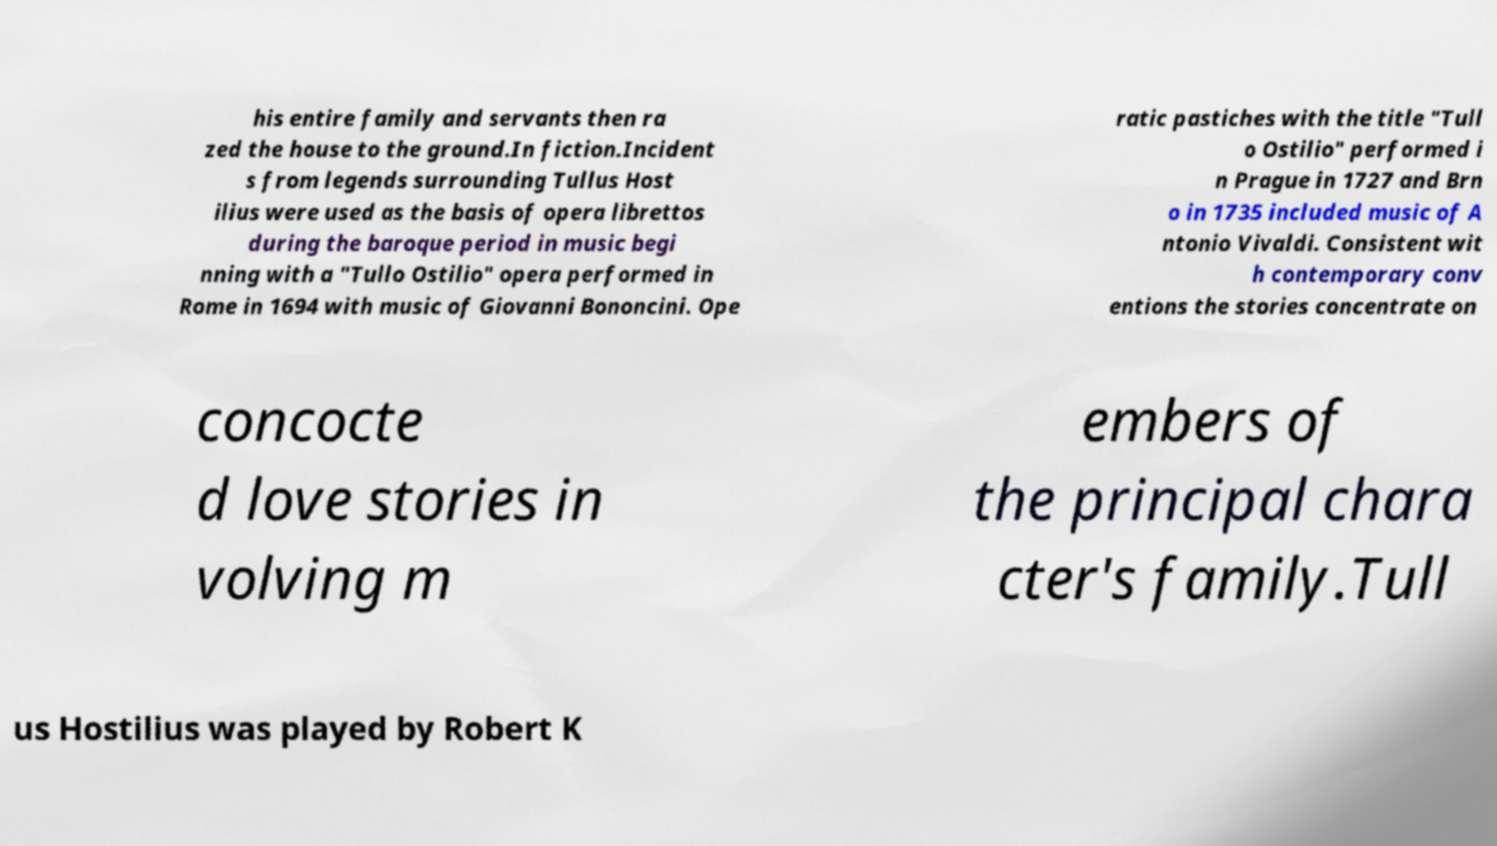There's text embedded in this image that I need extracted. Can you transcribe it verbatim? his entire family and servants then ra zed the house to the ground.In fiction.Incident s from legends surrounding Tullus Host ilius were used as the basis of opera librettos during the baroque period in music begi nning with a "Tullo Ostilio" opera performed in Rome in 1694 with music of Giovanni Bononcini. Ope ratic pastiches with the title "Tull o Ostilio" performed i n Prague in 1727 and Brn o in 1735 included music of A ntonio Vivaldi. Consistent wit h contemporary conv entions the stories concentrate on concocte d love stories in volving m embers of the principal chara cter's family.Tull us Hostilius was played by Robert K 